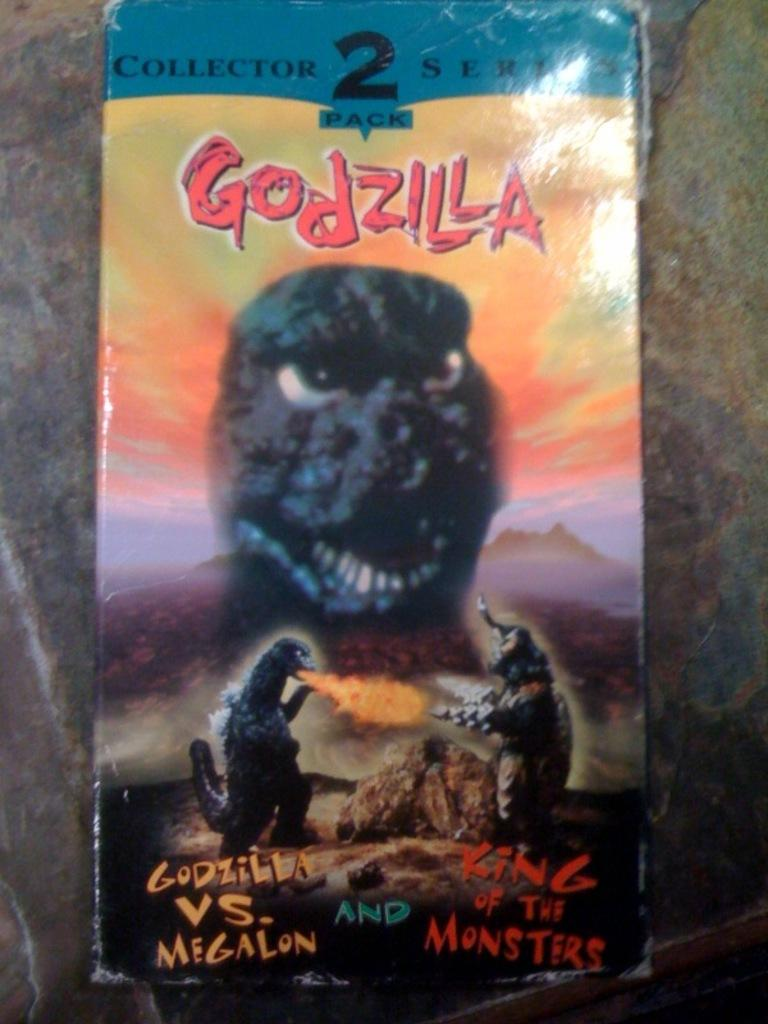What is located in the center of the image? There is a wall in the center of the image. What is on the wall? There is a poster on the wall. What is depicted on the poster? The poster features dragons. Are there any words on the poster? Yes, there is text on the poster. How many mittens are hanging on the wall in the image? There are no mittens present in the image; it features a wall with a poster of dragons. 